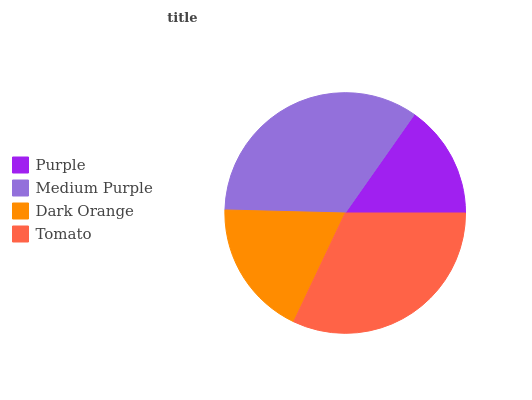Is Purple the minimum?
Answer yes or no. Yes. Is Medium Purple the maximum?
Answer yes or no. Yes. Is Dark Orange the minimum?
Answer yes or no. No. Is Dark Orange the maximum?
Answer yes or no. No. Is Medium Purple greater than Dark Orange?
Answer yes or no. Yes. Is Dark Orange less than Medium Purple?
Answer yes or no. Yes. Is Dark Orange greater than Medium Purple?
Answer yes or no. No. Is Medium Purple less than Dark Orange?
Answer yes or no. No. Is Tomato the high median?
Answer yes or no. Yes. Is Dark Orange the low median?
Answer yes or no. Yes. Is Medium Purple the high median?
Answer yes or no. No. Is Medium Purple the low median?
Answer yes or no. No. 